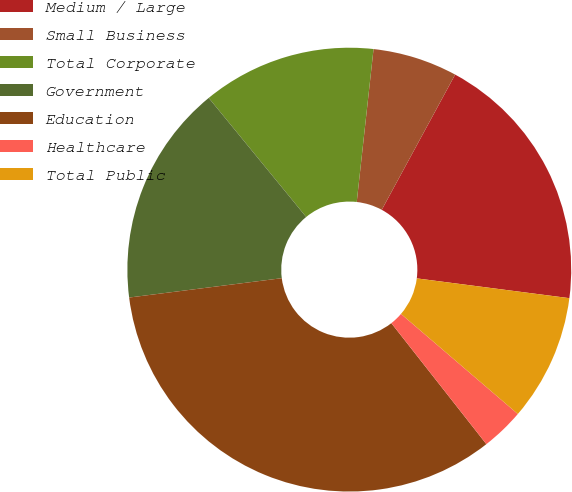Convert chart. <chart><loc_0><loc_0><loc_500><loc_500><pie_chart><fcel>Medium / Large<fcel>Small Business<fcel>Total Corporate<fcel>Government<fcel>Education<fcel>Healthcare<fcel>Total Public<nl><fcel>19.14%<fcel>6.17%<fcel>12.66%<fcel>16.09%<fcel>33.59%<fcel>3.13%<fcel>9.22%<nl></chart> 